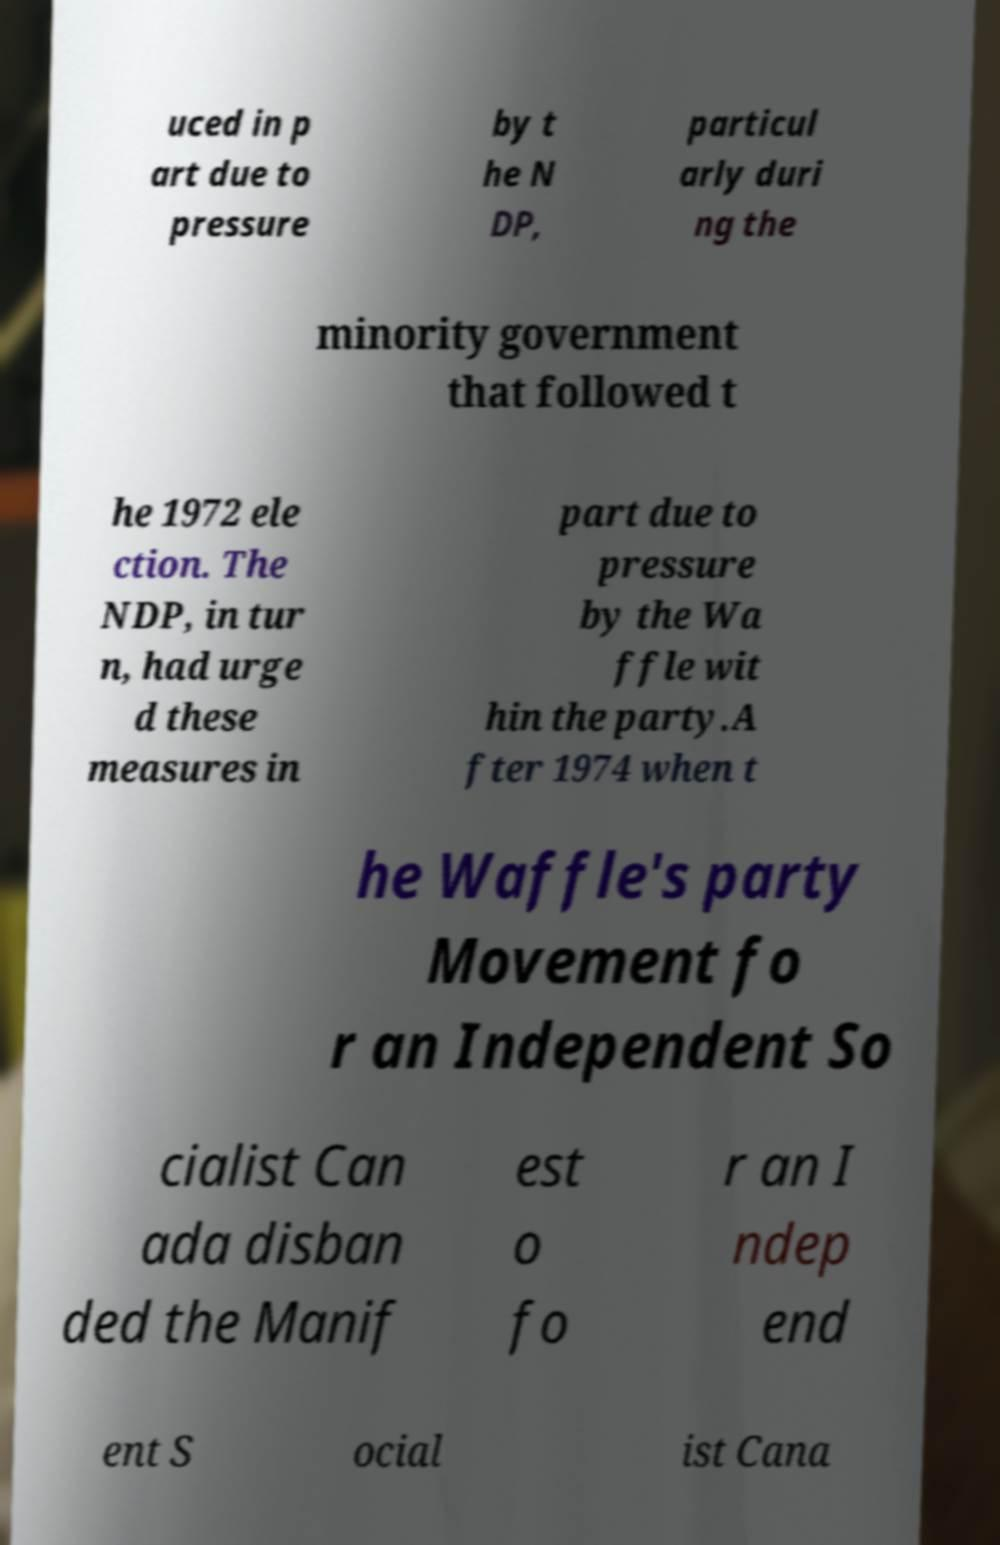There's text embedded in this image that I need extracted. Can you transcribe it verbatim? uced in p art due to pressure by t he N DP, particul arly duri ng the minority government that followed t he 1972 ele ction. The NDP, in tur n, had urge d these measures in part due to pressure by the Wa ffle wit hin the party.A fter 1974 when t he Waffle's party Movement fo r an Independent So cialist Can ada disban ded the Manif est o fo r an I ndep end ent S ocial ist Cana 